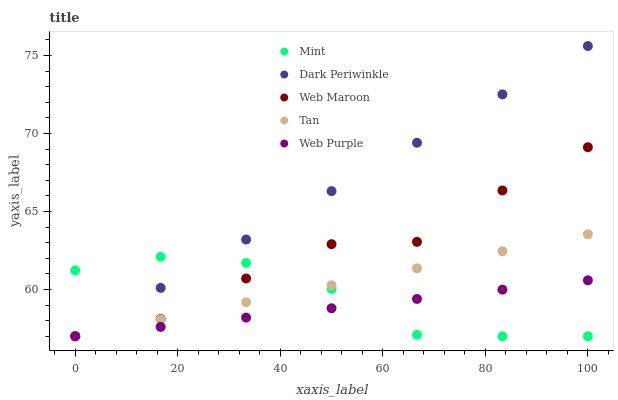Does Web Purple have the minimum area under the curve?
Answer yes or no. Yes. Does Dark Periwinkle have the maximum area under the curve?
Answer yes or no. Yes. Does Tan have the minimum area under the curve?
Answer yes or no. No. Does Tan have the maximum area under the curve?
Answer yes or no. No. Is Dark Periwinkle the smoothest?
Answer yes or no. Yes. Is Web Maroon the roughest?
Answer yes or no. Yes. Is Tan the smoothest?
Answer yes or no. No. Is Tan the roughest?
Answer yes or no. No. Does Web Maroon have the lowest value?
Answer yes or no. Yes. Does Dark Periwinkle have the highest value?
Answer yes or no. Yes. Does Tan have the highest value?
Answer yes or no. No. Does Tan intersect Web Purple?
Answer yes or no. Yes. Is Tan less than Web Purple?
Answer yes or no. No. Is Tan greater than Web Purple?
Answer yes or no. No. 